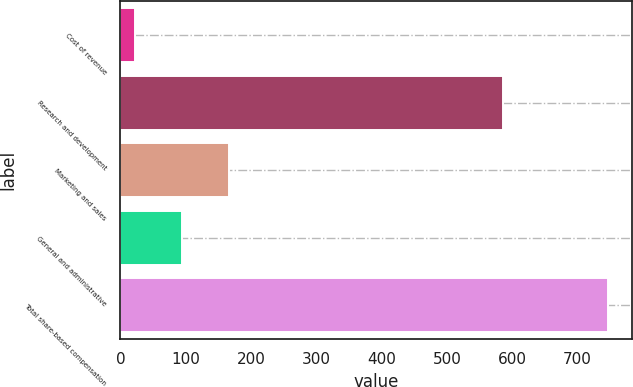Convert chart to OTSL. <chart><loc_0><loc_0><loc_500><loc_500><bar_chart><fcel>Cost of revenue<fcel>Research and development<fcel>Marketing and sales<fcel>General and administrative<fcel>Total share-based compensation<nl><fcel>22<fcel>586<fcel>166.8<fcel>94.4<fcel>746<nl></chart> 